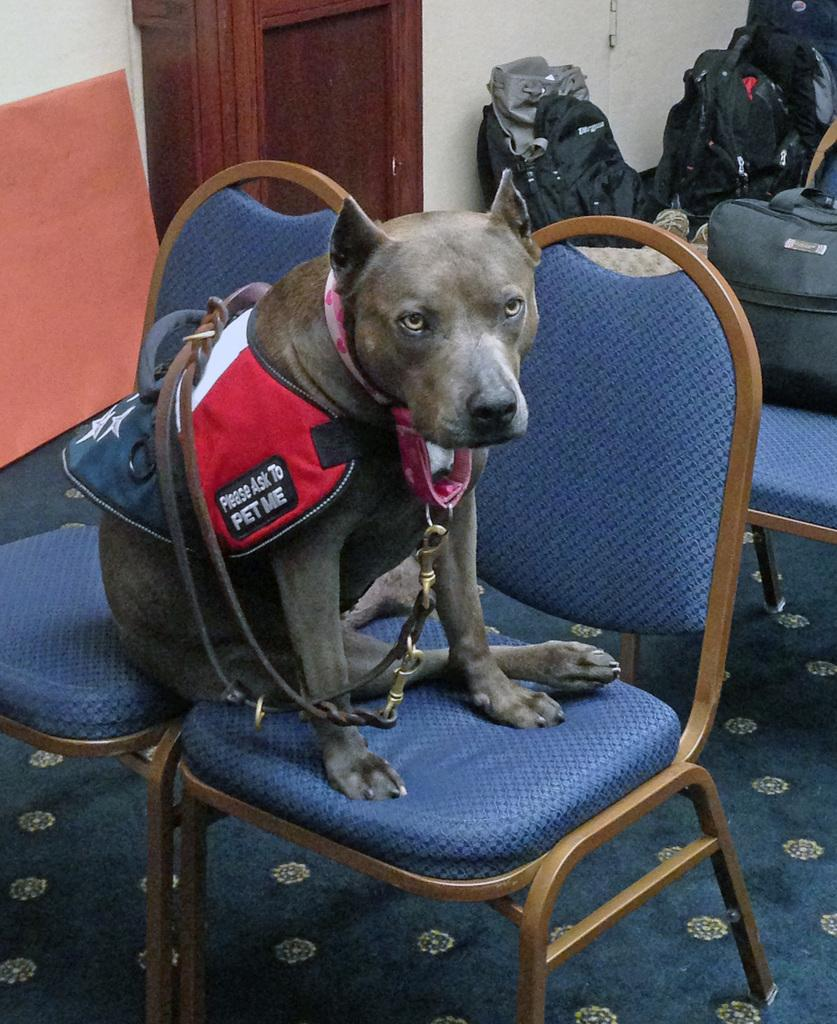What type of animal is in the image? There is a dog in the image. Where is the dog located? The dog is on a chair. What else can be seen in the image besides the dog? There are bags visible in the image. What is the surface that the chair and bags are resting on? There is a floor visible in the image. What is the background of the image? There is a wall in the image. What type of cloth is draped over the dog in the image? There is no cloth draped over the dog in the image. What details can be seen on the dog's fur in the image? The image does not provide enough detail to describe the dog's fur. 